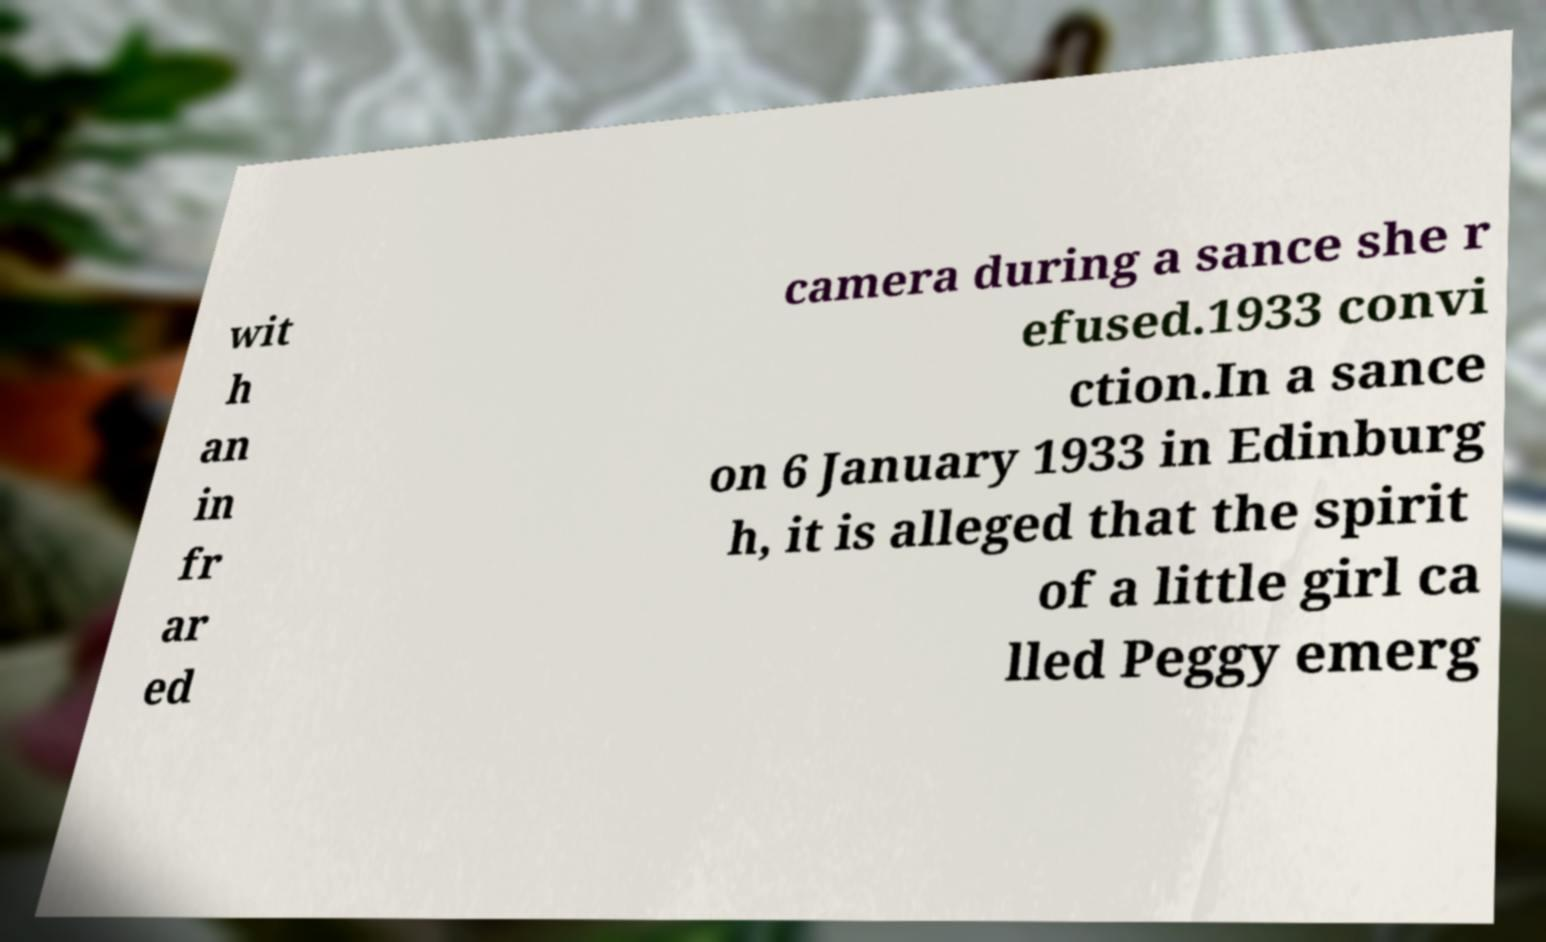Please read and relay the text visible in this image. What does it say? wit h an in fr ar ed camera during a sance she r efused.1933 convi ction.In a sance on 6 January 1933 in Edinburg h, it is alleged that the spirit of a little girl ca lled Peggy emerg 